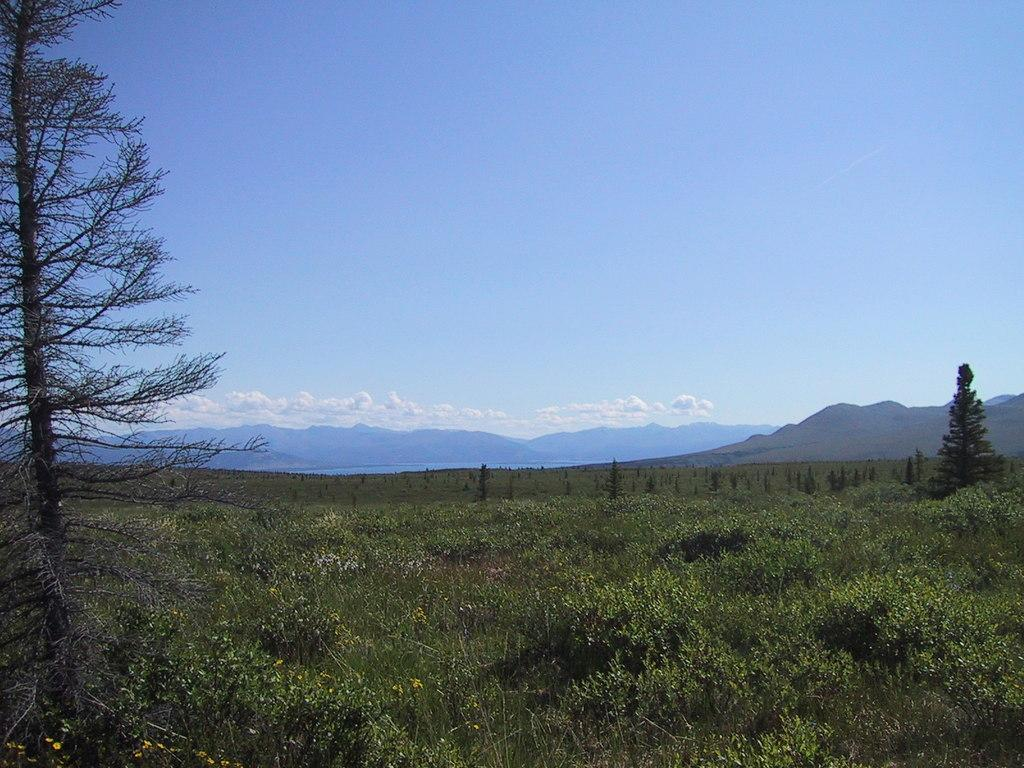What type of vegetation can be seen in the image? There are plants in the image. What is on the ground in the image? There is grass on the ground in the image. What can be seen in the distance in the image? There are trees and mountains in the background of the image. How would you describe the sky in the image? The sky is blue and cloudy in the image. What is the person writing in the image? There is no person present in the image, let alone someone writing. What is the source of the surprise in the image? There is no surprise or any indication of surprise in the image. 